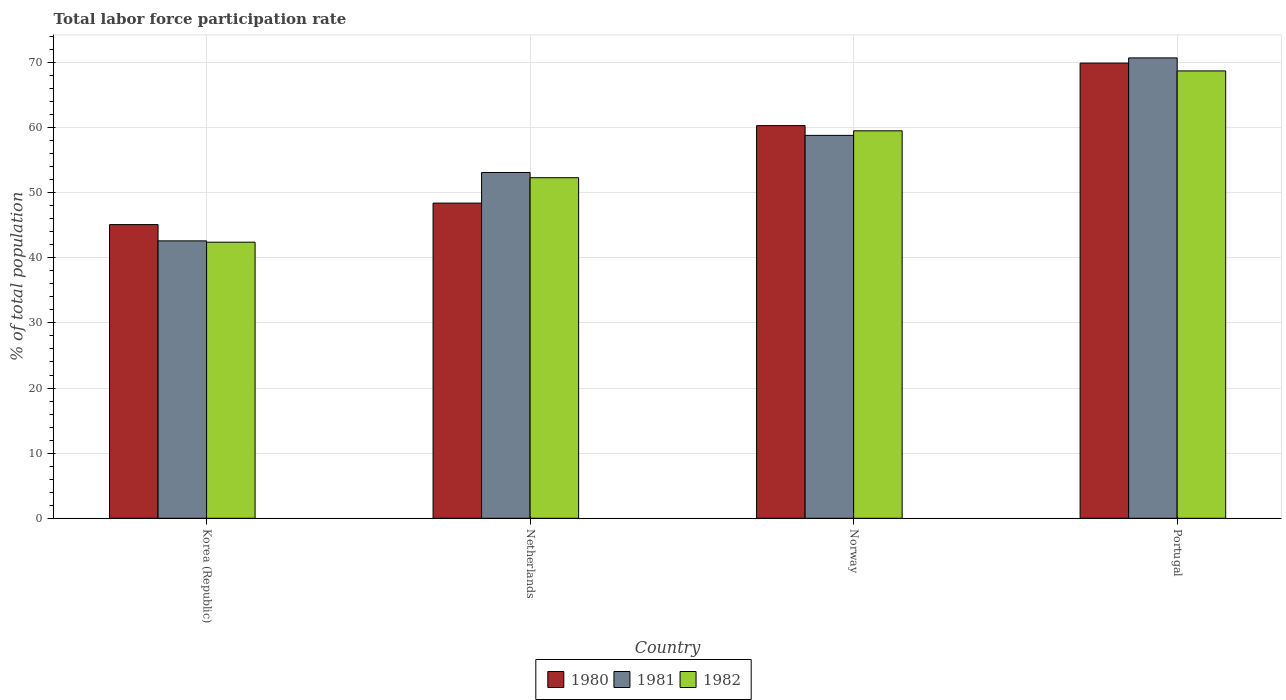How many different coloured bars are there?
Make the answer very short. 3. How many groups of bars are there?
Provide a succinct answer. 4. Are the number of bars per tick equal to the number of legend labels?
Ensure brevity in your answer.  Yes. How many bars are there on the 4th tick from the left?
Give a very brief answer. 3. How many bars are there on the 2nd tick from the right?
Provide a short and direct response. 3. What is the label of the 4th group of bars from the left?
Provide a short and direct response. Portugal. In how many cases, is the number of bars for a given country not equal to the number of legend labels?
Provide a succinct answer. 0. What is the total labor force participation rate in 1980 in Norway?
Your answer should be very brief. 60.3. Across all countries, what is the maximum total labor force participation rate in 1980?
Your response must be concise. 69.9. Across all countries, what is the minimum total labor force participation rate in 1982?
Keep it short and to the point. 42.4. What is the total total labor force participation rate in 1982 in the graph?
Provide a succinct answer. 222.9. What is the difference between the total labor force participation rate in 1980 in Korea (Republic) and that in Netherlands?
Your response must be concise. -3.3. What is the difference between the total labor force participation rate in 1980 in Norway and the total labor force participation rate in 1982 in Korea (Republic)?
Offer a very short reply. 17.9. What is the average total labor force participation rate in 1981 per country?
Your response must be concise. 56.3. What is the difference between the total labor force participation rate of/in 1980 and total labor force participation rate of/in 1981 in Korea (Republic)?
Provide a short and direct response. 2.5. In how many countries, is the total labor force participation rate in 1981 greater than 70 %?
Provide a short and direct response. 1. What is the ratio of the total labor force participation rate in 1982 in Korea (Republic) to that in Norway?
Offer a very short reply. 0.71. What is the difference between the highest and the second highest total labor force participation rate in 1980?
Give a very brief answer. -11.9. What is the difference between the highest and the lowest total labor force participation rate in 1982?
Make the answer very short. 26.3. In how many countries, is the total labor force participation rate in 1981 greater than the average total labor force participation rate in 1981 taken over all countries?
Your answer should be very brief. 2. Is the sum of the total labor force participation rate in 1980 in Netherlands and Norway greater than the maximum total labor force participation rate in 1982 across all countries?
Provide a short and direct response. Yes. What does the 2nd bar from the right in Portugal represents?
Offer a terse response. 1981. Is it the case that in every country, the sum of the total labor force participation rate in 1982 and total labor force participation rate in 1980 is greater than the total labor force participation rate in 1981?
Provide a succinct answer. Yes. How many bars are there?
Your answer should be very brief. 12. Are all the bars in the graph horizontal?
Keep it short and to the point. No. What is the difference between two consecutive major ticks on the Y-axis?
Your answer should be very brief. 10. Where does the legend appear in the graph?
Keep it short and to the point. Bottom center. How are the legend labels stacked?
Give a very brief answer. Horizontal. What is the title of the graph?
Your response must be concise. Total labor force participation rate. Does "1975" appear as one of the legend labels in the graph?
Give a very brief answer. No. What is the label or title of the Y-axis?
Your answer should be compact. % of total population. What is the % of total population of 1980 in Korea (Republic)?
Your answer should be very brief. 45.1. What is the % of total population in 1981 in Korea (Republic)?
Ensure brevity in your answer.  42.6. What is the % of total population of 1982 in Korea (Republic)?
Keep it short and to the point. 42.4. What is the % of total population in 1980 in Netherlands?
Make the answer very short. 48.4. What is the % of total population in 1981 in Netherlands?
Offer a very short reply. 53.1. What is the % of total population of 1982 in Netherlands?
Provide a succinct answer. 52.3. What is the % of total population of 1980 in Norway?
Keep it short and to the point. 60.3. What is the % of total population in 1981 in Norway?
Offer a very short reply. 58.8. What is the % of total population in 1982 in Norway?
Give a very brief answer. 59.5. What is the % of total population in 1980 in Portugal?
Offer a terse response. 69.9. What is the % of total population in 1981 in Portugal?
Your answer should be compact. 70.7. What is the % of total population in 1982 in Portugal?
Your response must be concise. 68.7. Across all countries, what is the maximum % of total population in 1980?
Offer a very short reply. 69.9. Across all countries, what is the maximum % of total population in 1981?
Give a very brief answer. 70.7. Across all countries, what is the maximum % of total population in 1982?
Provide a succinct answer. 68.7. Across all countries, what is the minimum % of total population in 1980?
Make the answer very short. 45.1. Across all countries, what is the minimum % of total population of 1981?
Keep it short and to the point. 42.6. Across all countries, what is the minimum % of total population of 1982?
Your answer should be compact. 42.4. What is the total % of total population of 1980 in the graph?
Ensure brevity in your answer.  223.7. What is the total % of total population of 1981 in the graph?
Keep it short and to the point. 225.2. What is the total % of total population in 1982 in the graph?
Provide a succinct answer. 222.9. What is the difference between the % of total population in 1980 in Korea (Republic) and that in Netherlands?
Give a very brief answer. -3.3. What is the difference between the % of total population of 1980 in Korea (Republic) and that in Norway?
Your answer should be compact. -15.2. What is the difference between the % of total population of 1981 in Korea (Republic) and that in Norway?
Your answer should be very brief. -16.2. What is the difference between the % of total population in 1982 in Korea (Republic) and that in Norway?
Ensure brevity in your answer.  -17.1. What is the difference between the % of total population of 1980 in Korea (Republic) and that in Portugal?
Offer a very short reply. -24.8. What is the difference between the % of total population of 1981 in Korea (Republic) and that in Portugal?
Your answer should be very brief. -28.1. What is the difference between the % of total population in 1982 in Korea (Republic) and that in Portugal?
Your answer should be compact. -26.3. What is the difference between the % of total population of 1980 in Netherlands and that in Portugal?
Ensure brevity in your answer.  -21.5. What is the difference between the % of total population in 1981 in Netherlands and that in Portugal?
Offer a terse response. -17.6. What is the difference between the % of total population in 1982 in Netherlands and that in Portugal?
Offer a terse response. -16.4. What is the difference between the % of total population of 1982 in Norway and that in Portugal?
Your answer should be compact. -9.2. What is the difference between the % of total population in 1980 in Korea (Republic) and the % of total population in 1982 in Netherlands?
Offer a terse response. -7.2. What is the difference between the % of total population in 1981 in Korea (Republic) and the % of total population in 1982 in Netherlands?
Your answer should be very brief. -9.7. What is the difference between the % of total population of 1980 in Korea (Republic) and the % of total population of 1981 in Norway?
Offer a very short reply. -13.7. What is the difference between the % of total population of 1980 in Korea (Republic) and the % of total population of 1982 in Norway?
Offer a terse response. -14.4. What is the difference between the % of total population of 1981 in Korea (Republic) and the % of total population of 1982 in Norway?
Your response must be concise. -16.9. What is the difference between the % of total population in 1980 in Korea (Republic) and the % of total population in 1981 in Portugal?
Provide a short and direct response. -25.6. What is the difference between the % of total population in 1980 in Korea (Republic) and the % of total population in 1982 in Portugal?
Provide a succinct answer. -23.6. What is the difference between the % of total population in 1981 in Korea (Republic) and the % of total population in 1982 in Portugal?
Make the answer very short. -26.1. What is the difference between the % of total population of 1981 in Netherlands and the % of total population of 1982 in Norway?
Keep it short and to the point. -6.4. What is the difference between the % of total population in 1980 in Netherlands and the % of total population in 1981 in Portugal?
Make the answer very short. -22.3. What is the difference between the % of total population in 1980 in Netherlands and the % of total population in 1982 in Portugal?
Offer a very short reply. -20.3. What is the difference between the % of total population of 1981 in Netherlands and the % of total population of 1982 in Portugal?
Ensure brevity in your answer.  -15.6. What is the difference between the % of total population of 1980 in Norway and the % of total population of 1981 in Portugal?
Ensure brevity in your answer.  -10.4. What is the average % of total population in 1980 per country?
Your answer should be very brief. 55.92. What is the average % of total population in 1981 per country?
Offer a very short reply. 56.3. What is the average % of total population of 1982 per country?
Your response must be concise. 55.73. What is the difference between the % of total population of 1980 and % of total population of 1982 in Norway?
Your response must be concise. 0.8. What is the difference between the % of total population of 1981 and % of total population of 1982 in Norway?
Keep it short and to the point. -0.7. What is the difference between the % of total population of 1980 and % of total population of 1982 in Portugal?
Your answer should be very brief. 1.2. What is the difference between the % of total population of 1981 and % of total population of 1982 in Portugal?
Your answer should be compact. 2. What is the ratio of the % of total population of 1980 in Korea (Republic) to that in Netherlands?
Your answer should be very brief. 0.93. What is the ratio of the % of total population of 1981 in Korea (Republic) to that in Netherlands?
Provide a succinct answer. 0.8. What is the ratio of the % of total population in 1982 in Korea (Republic) to that in Netherlands?
Your answer should be very brief. 0.81. What is the ratio of the % of total population of 1980 in Korea (Republic) to that in Norway?
Your answer should be compact. 0.75. What is the ratio of the % of total population in 1981 in Korea (Republic) to that in Norway?
Make the answer very short. 0.72. What is the ratio of the % of total population of 1982 in Korea (Republic) to that in Norway?
Give a very brief answer. 0.71. What is the ratio of the % of total population in 1980 in Korea (Republic) to that in Portugal?
Offer a terse response. 0.65. What is the ratio of the % of total population of 1981 in Korea (Republic) to that in Portugal?
Your answer should be very brief. 0.6. What is the ratio of the % of total population in 1982 in Korea (Republic) to that in Portugal?
Offer a very short reply. 0.62. What is the ratio of the % of total population in 1980 in Netherlands to that in Norway?
Your response must be concise. 0.8. What is the ratio of the % of total population of 1981 in Netherlands to that in Norway?
Provide a short and direct response. 0.9. What is the ratio of the % of total population of 1982 in Netherlands to that in Norway?
Keep it short and to the point. 0.88. What is the ratio of the % of total population of 1980 in Netherlands to that in Portugal?
Provide a succinct answer. 0.69. What is the ratio of the % of total population in 1981 in Netherlands to that in Portugal?
Offer a very short reply. 0.75. What is the ratio of the % of total population of 1982 in Netherlands to that in Portugal?
Give a very brief answer. 0.76. What is the ratio of the % of total population in 1980 in Norway to that in Portugal?
Offer a terse response. 0.86. What is the ratio of the % of total population in 1981 in Norway to that in Portugal?
Your answer should be very brief. 0.83. What is the ratio of the % of total population of 1982 in Norway to that in Portugal?
Your answer should be compact. 0.87. What is the difference between the highest and the lowest % of total population of 1980?
Make the answer very short. 24.8. What is the difference between the highest and the lowest % of total population in 1981?
Ensure brevity in your answer.  28.1. What is the difference between the highest and the lowest % of total population in 1982?
Your answer should be very brief. 26.3. 